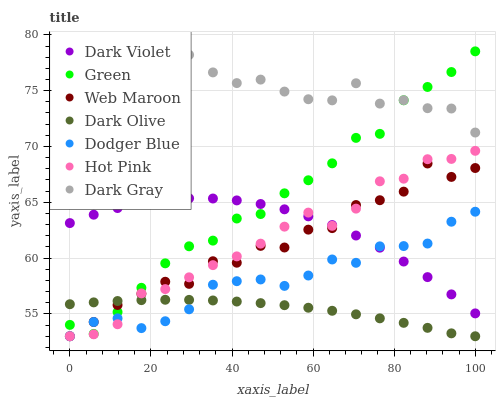Does Dark Olive have the minimum area under the curve?
Answer yes or no. Yes. Does Dark Gray have the maximum area under the curve?
Answer yes or no. Yes. Does Hot Pink have the minimum area under the curve?
Answer yes or no. No. Does Hot Pink have the maximum area under the curve?
Answer yes or no. No. Is Dark Olive the smoothest?
Answer yes or no. Yes. Is Dark Gray the roughest?
Answer yes or no. Yes. Is Hot Pink the smoothest?
Answer yes or no. No. Is Hot Pink the roughest?
Answer yes or no. No. Does Dark Olive have the lowest value?
Answer yes or no. Yes. Does Dark Violet have the lowest value?
Answer yes or no. No. Does Dark Gray have the highest value?
Answer yes or no. Yes. Does Hot Pink have the highest value?
Answer yes or no. No. Is Dodger Blue less than Dark Gray?
Answer yes or no. Yes. Is Dark Violet greater than Dark Olive?
Answer yes or no. Yes. Does Web Maroon intersect Green?
Answer yes or no. Yes. Is Web Maroon less than Green?
Answer yes or no. No. Is Web Maroon greater than Green?
Answer yes or no. No. Does Dodger Blue intersect Dark Gray?
Answer yes or no. No. 